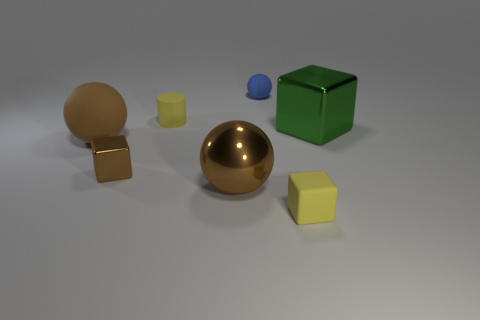Are there any shiny cubes?
Your response must be concise. Yes. Does the large block have the same color as the small ball that is behind the tiny yellow matte block?
Your response must be concise. No. The tiny rubber ball is what color?
Keep it short and to the point. Blue. Is there any other thing that has the same shape as the big brown metallic object?
Offer a very short reply. Yes. The tiny matte object that is the same shape as the large brown rubber object is what color?
Your answer should be very brief. Blue. Is the brown matte thing the same shape as the tiny blue thing?
Offer a very short reply. Yes. What number of spheres are big matte objects or small yellow objects?
Give a very brief answer. 1. There is a tiny cube that is made of the same material as the large green thing; what color is it?
Your answer should be very brief. Brown. There is a matte ball that is in front of the green shiny block; is it the same size as the big green metal block?
Ensure brevity in your answer.  Yes. Do the yellow cylinder and the big brown sphere that is to the right of the tiny matte cylinder have the same material?
Your response must be concise. No. 